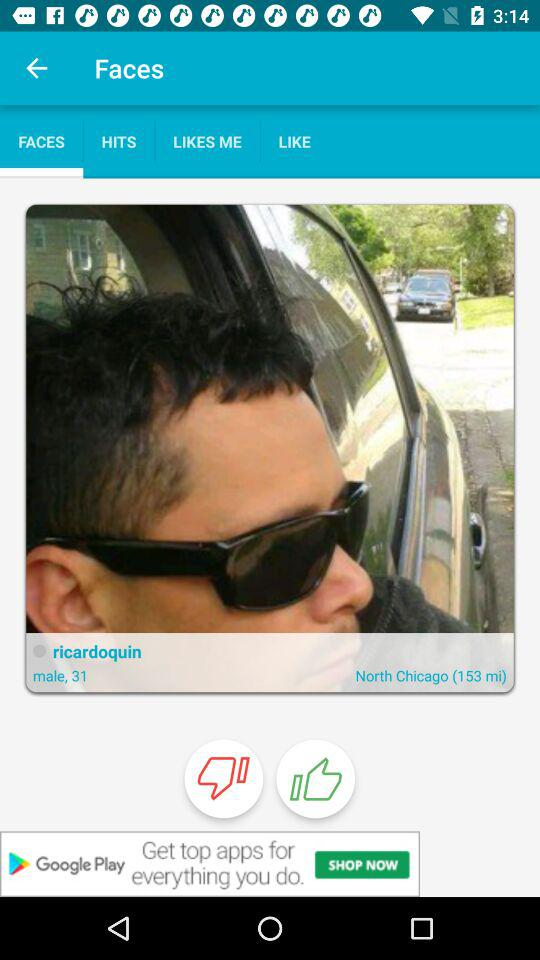What is the gender of "ricardoquin"? "ricardoquin" is a male. 